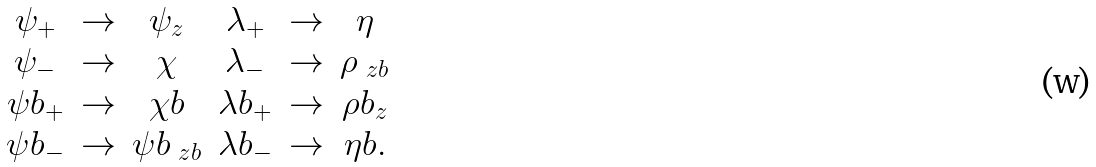Convert formula to latex. <formula><loc_0><loc_0><loc_500><loc_500>\begin{array} { c c c c c c } \psi _ { + } & \to & \psi _ { z } & \lambda _ { + } & \to & \eta \\ \psi _ { - } & \to & \chi & \lambda _ { - } & \to & \rho _ { \ z b } \\ \psi b _ { + } & \to & \chi b & \lambda b _ { + } & \to & \rho b _ { z } \\ \psi b _ { - } & \to & \psi b _ { \ z b } & \lambda b _ { - } & \to & \eta b . \end{array}</formula> 